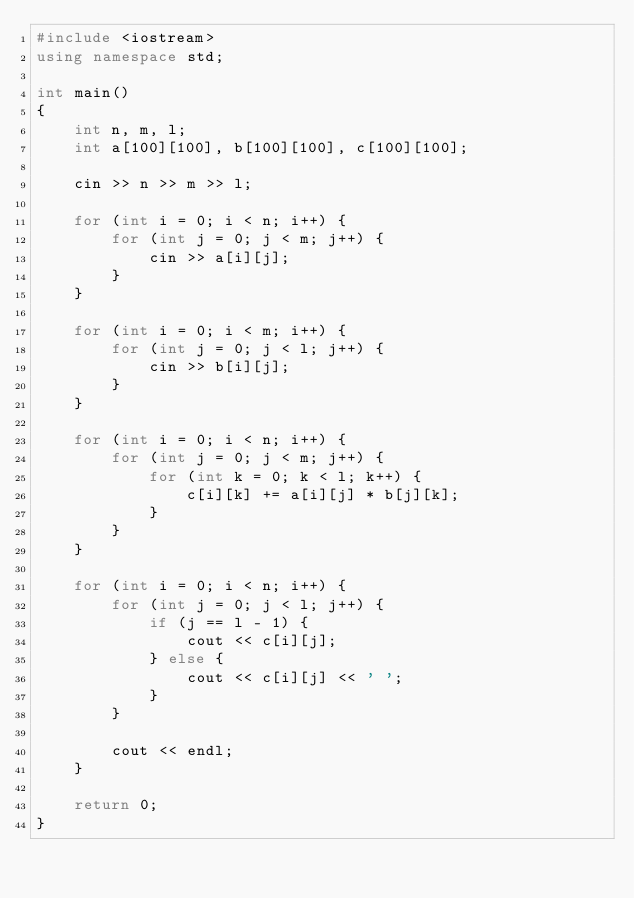<code> <loc_0><loc_0><loc_500><loc_500><_C++_>#include <iostream>
using namespace std;

int main()
{
    int n, m, l;
    int a[100][100], b[100][100], c[100][100];

    cin >> n >> m >> l;

    for (int i = 0; i < n; i++) {
        for (int j = 0; j < m; j++) {
            cin >> a[i][j];
        }
    }

    for (int i = 0; i < m; i++) {
        for (int j = 0; j < l; j++) {
            cin >> b[i][j];
        }
    }

    for (int i = 0; i < n; i++) {
        for (int j = 0; j < m; j++) {
            for (int k = 0; k < l; k++) {
                c[i][k] += a[i][j] * b[j][k];
            }
        }
    }

    for (int i = 0; i < n; i++) {
        for (int j = 0; j < l; j++) {
            if (j == l - 1) {
                cout << c[i][j];
            } else {
                cout << c[i][j] << ' ';
            }
        }

        cout << endl;
    }

    return 0;
}</code> 